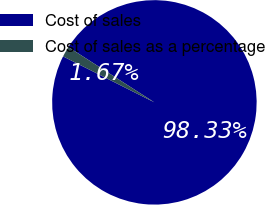<chart> <loc_0><loc_0><loc_500><loc_500><pie_chart><fcel>Cost of sales<fcel>Cost of sales as a percentage<nl><fcel>98.33%<fcel>1.67%<nl></chart> 